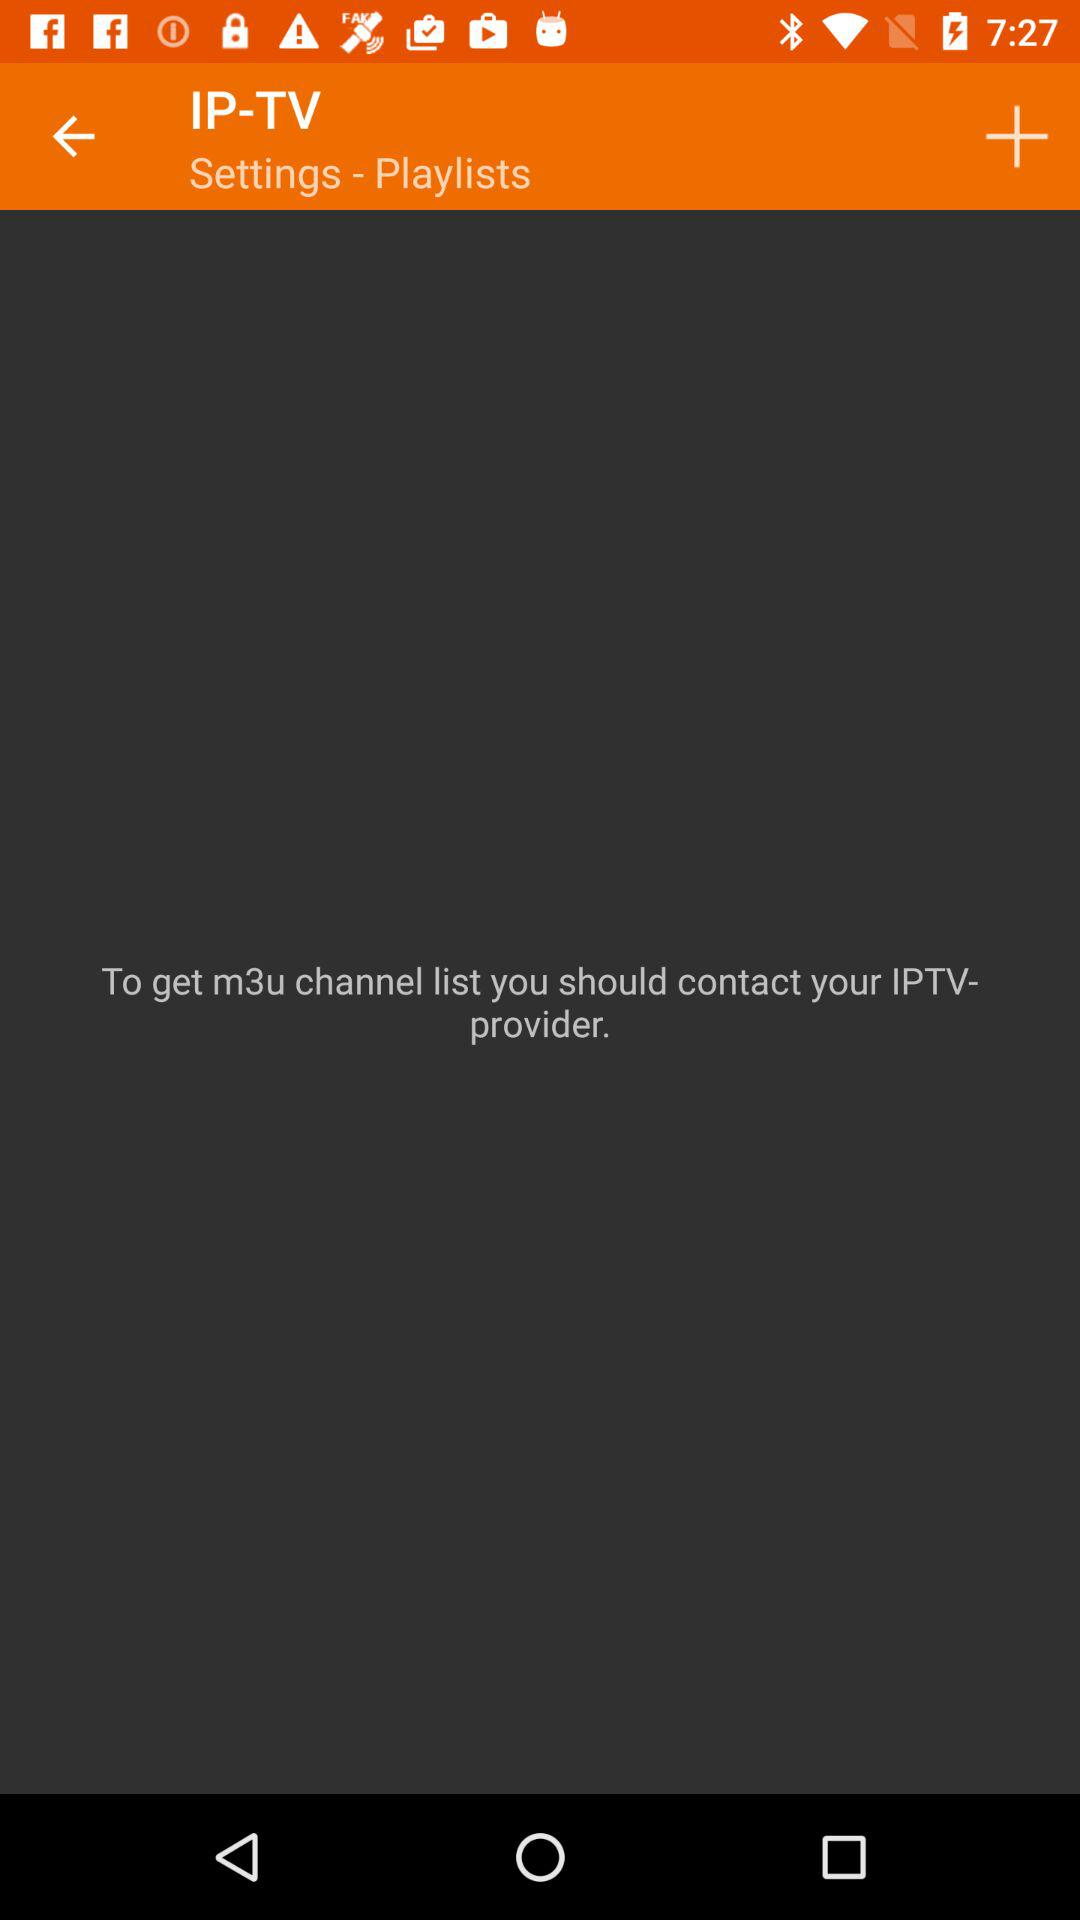What provider should I contact to get the "m3u" channel? You should contact your IPTV provider to get the "m3u" channel. 